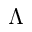Convert formula to latex. <formula><loc_0><loc_0><loc_500><loc_500>\Lambda</formula> 